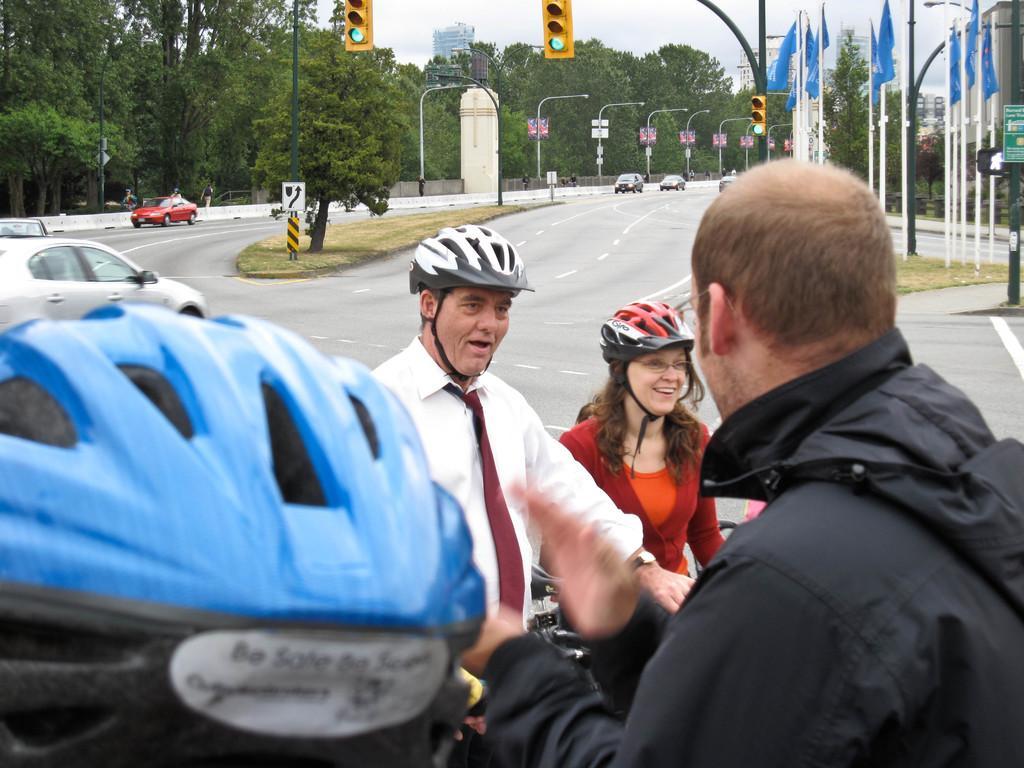In one or two sentences, can you explain what this image depicts? In this picture I can see trees, buildings and few poles with traffic signal lights and I can see pole lights and few flags and I can see sign board and a board with some text on the right side and I can see few people are standing and few of them wore helmets on their heads and looks like they are riding bicycles and I can see few cars moving on the road. 